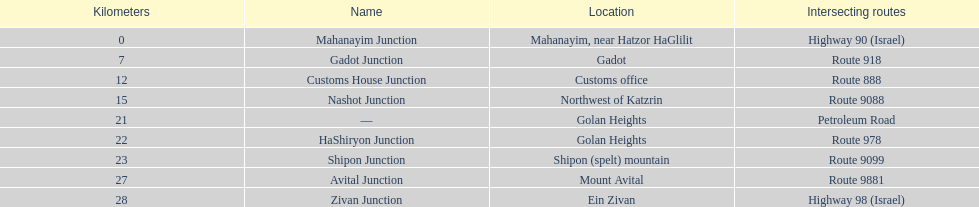On highway 91, is ein zivan closer to gadot junction or shipon junction? Gadot Junction. 